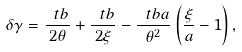Convert formula to latex. <formula><loc_0><loc_0><loc_500><loc_500>\delta \gamma = \frac { \ t b } { 2 \theta } + \frac { \ t b } { 2 \xi } - \frac { \ t b a } { \theta ^ { 2 } } \left ( \frac { \xi } { a } - 1 \right ) ,</formula> 